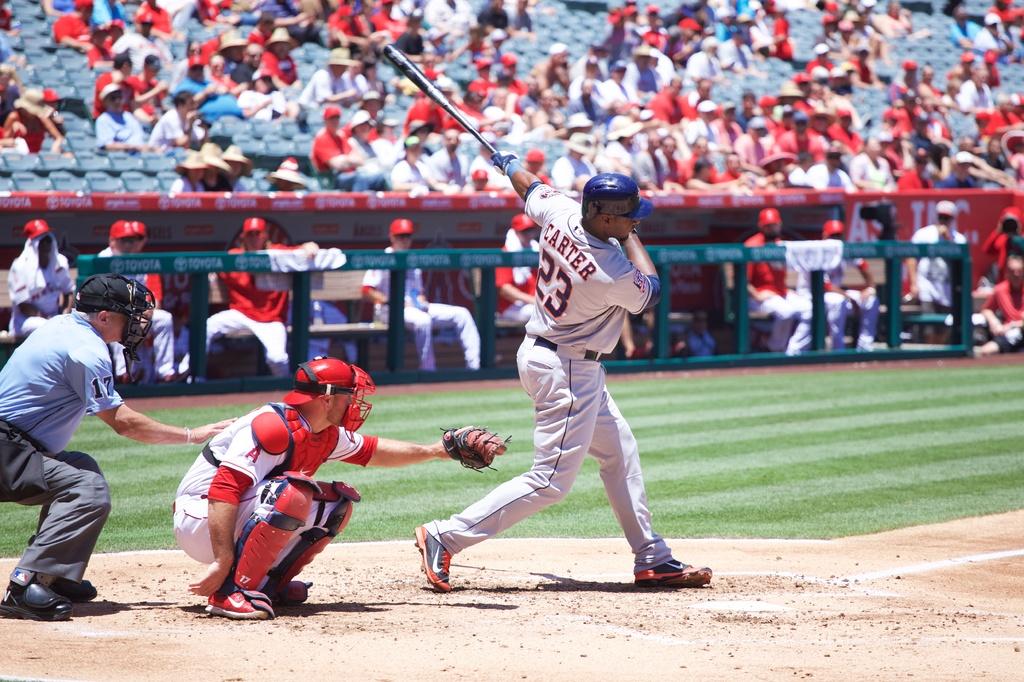What is the last name of the batter?
Your answer should be very brief. Carter. What number is the batter?
Make the answer very short. 23. 